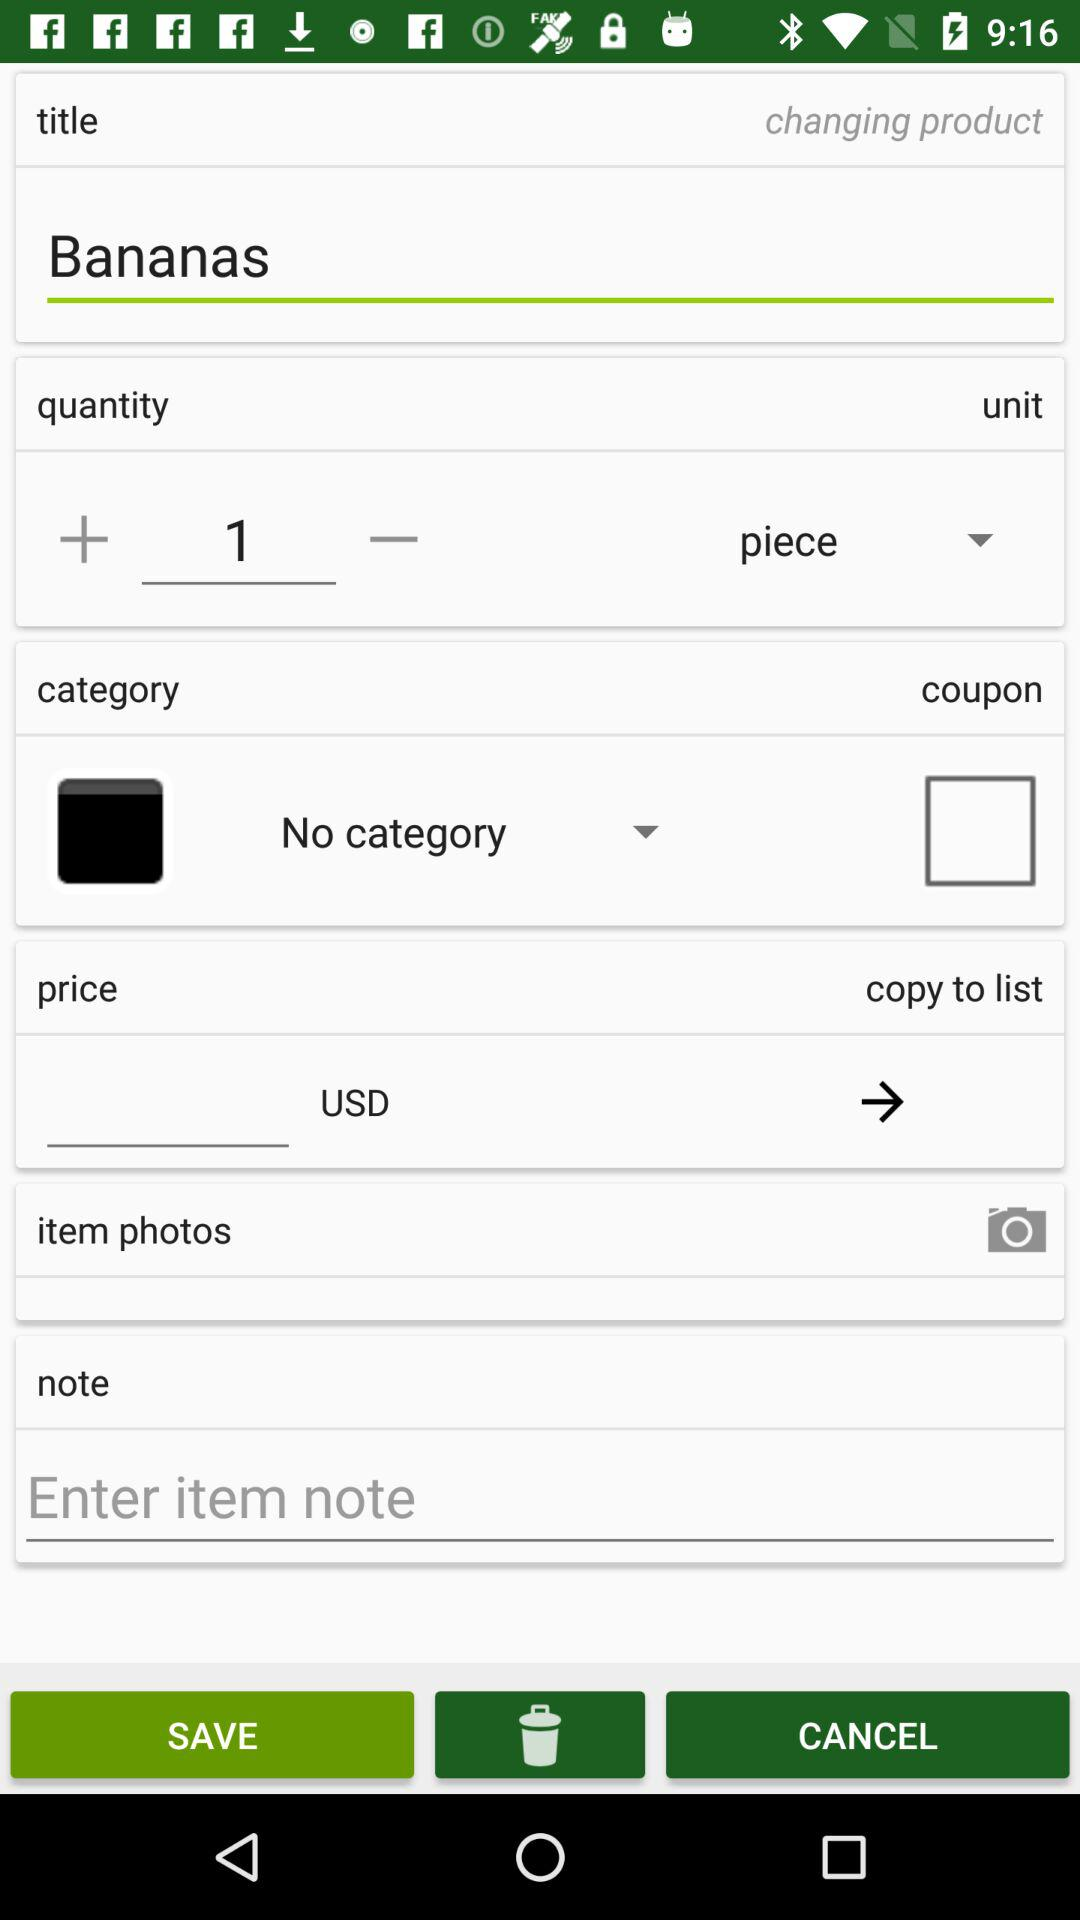What is the quantity? The quantity is 1. 